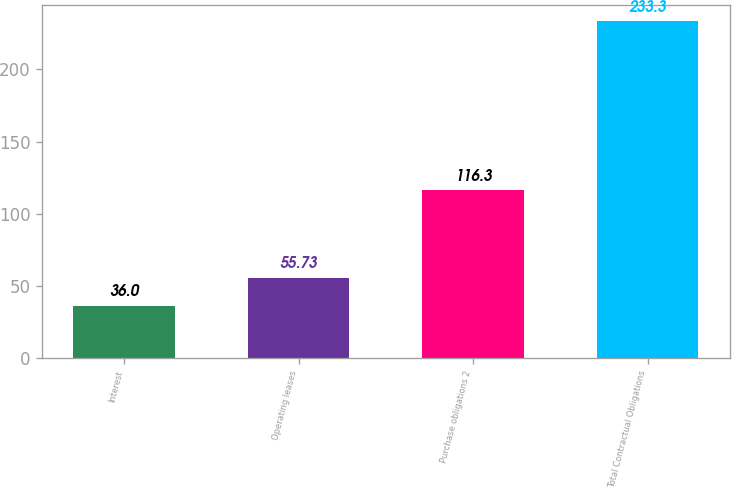Convert chart to OTSL. <chart><loc_0><loc_0><loc_500><loc_500><bar_chart><fcel>Interest<fcel>Operating leases<fcel>Purchase obligations 2<fcel>Total Contractual Obligations<nl><fcel>36<fcel>55.73<fcel>116.3<fcel>233.3<nl></chart> 